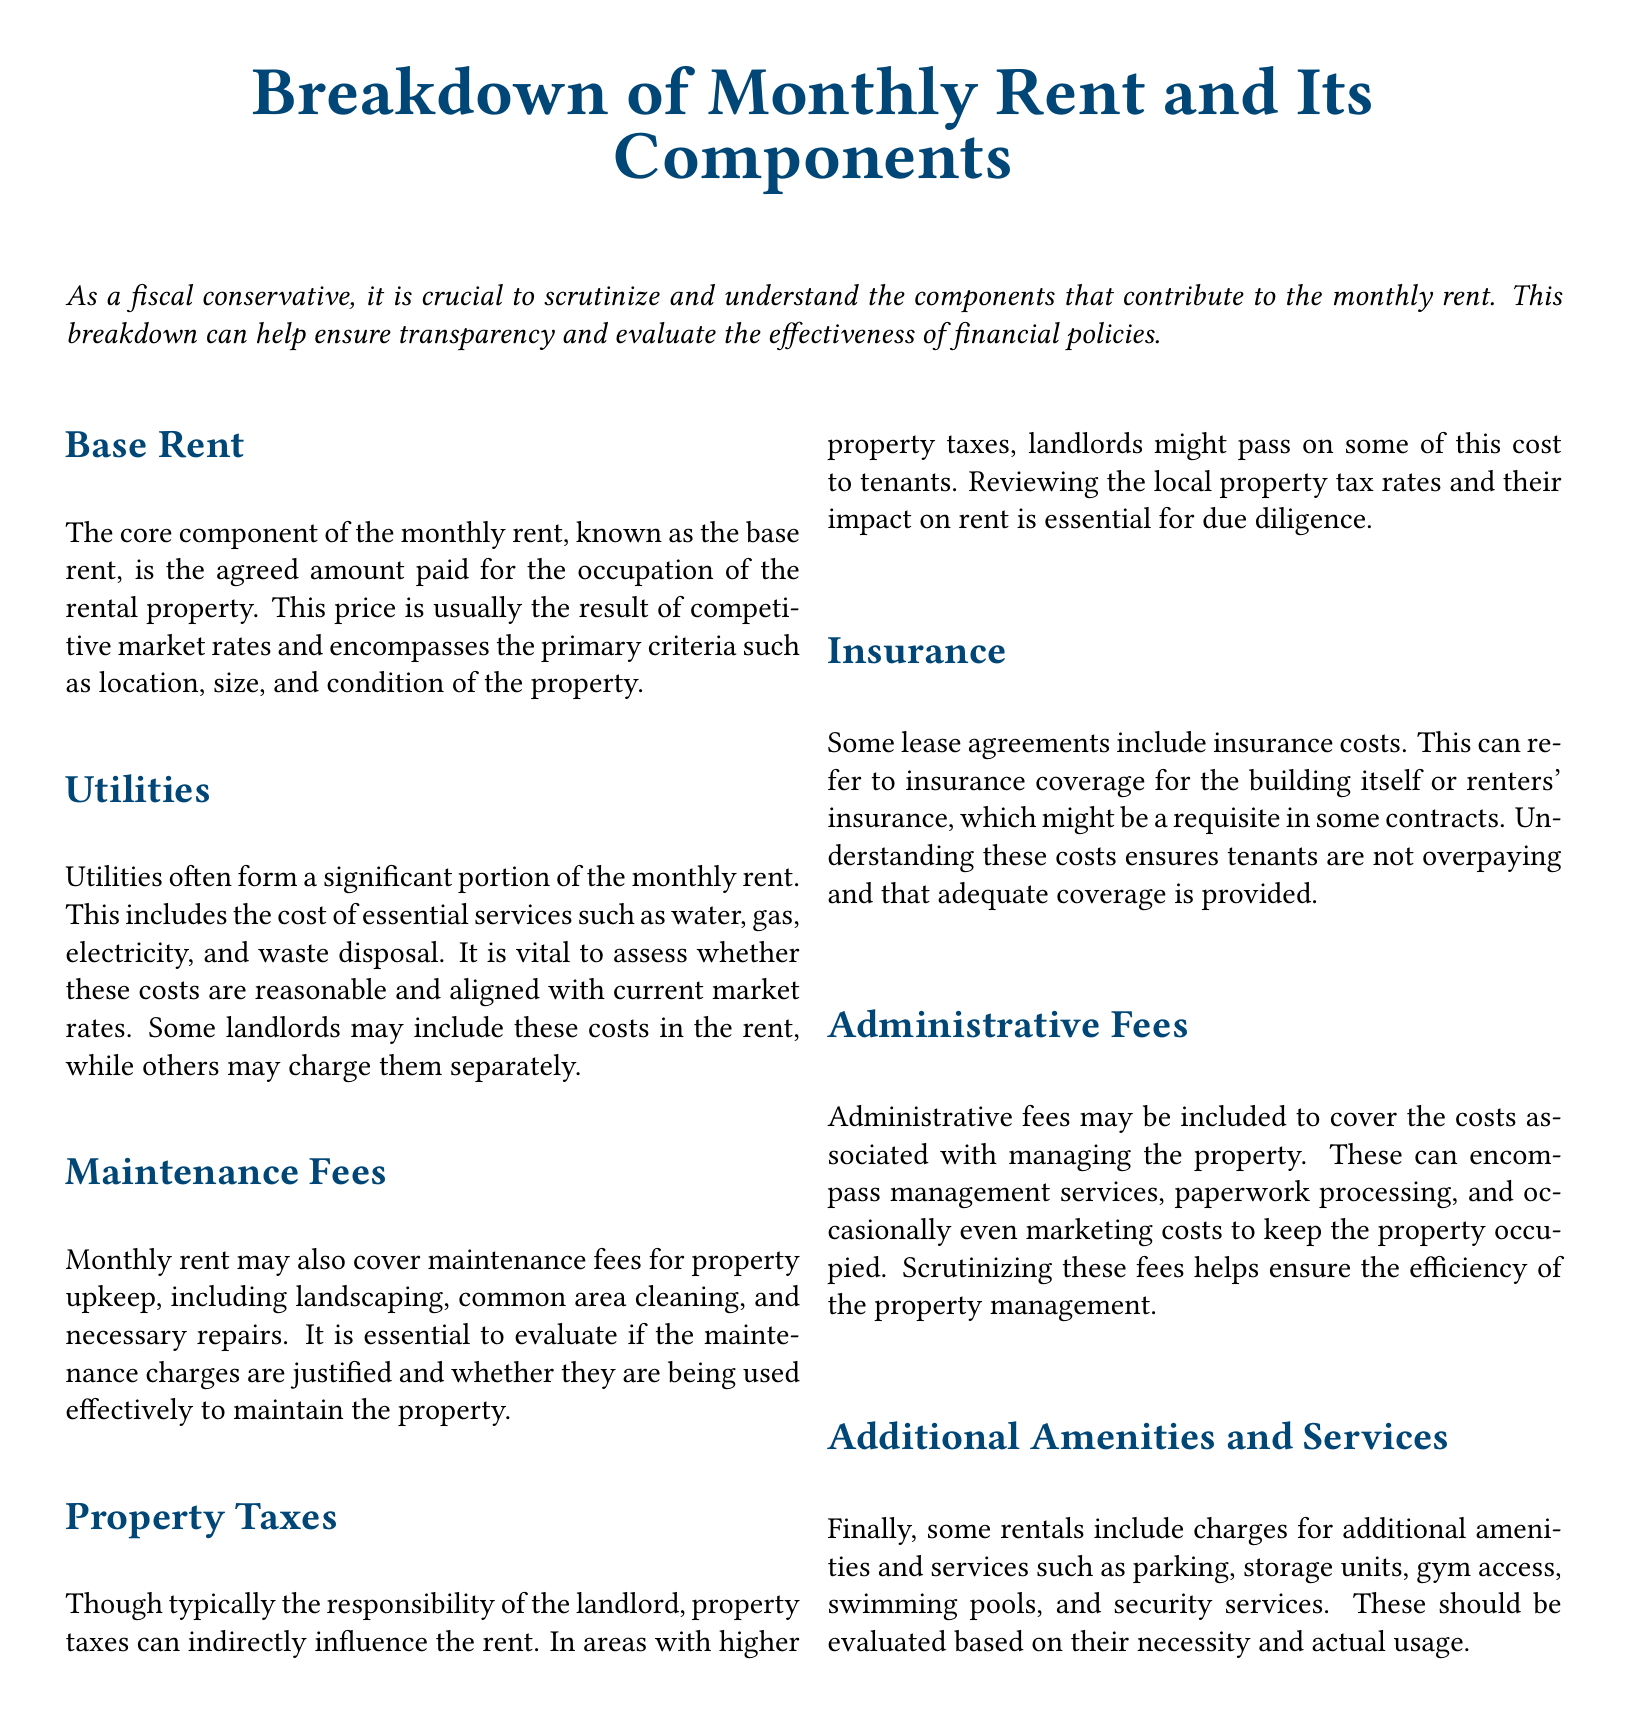What is the core component of the monthly rent? The core component of the monthly rent is the base rent, which is the agreed amount paid for the occupation of the rental property.
Answer: base rent What services are included in utilities? Utilities include essential services such as water, gas, electricity, and waste disposal.
Answer: water, gas, electricity, waste disposal What may maintenance fees cover? Maintenance fees cover property upkeep, including landscaping, common area cleaning, and necessary repairs.
Answer: property upkeep Who typically bears the responsibility for property taxes? Property taxes are typically the responsibility of the landlord.
Answer: landlord What do administrative fees cover? Administrative fees cover the costs associated with managing the property, including management services and paperwork processing.
Answer: management services, paperwork processing How should additional amenities be evaluated? Additional amenities should be evaluated based on their necessity and actual usage.
Answer: necessity and actual usage In what way can property taxes influence rent? Higher property taxes can indirectly influence the rent as landlords might pass on some of this cost to tenants.
Answer: pass on costs What is the role of insurance in a lease agreement? Insurance includes coverage for the building or renters' insurance, which might be required in some contracts.
Answer: coverage for the building or renters' insurance What is the overall purpose of the breakdown of monthly rent? The purpose of the breakdown is to ensure transparency and evaluate the effectiveness of financial policies.
Answer: transparency and evaluate effectiveness 